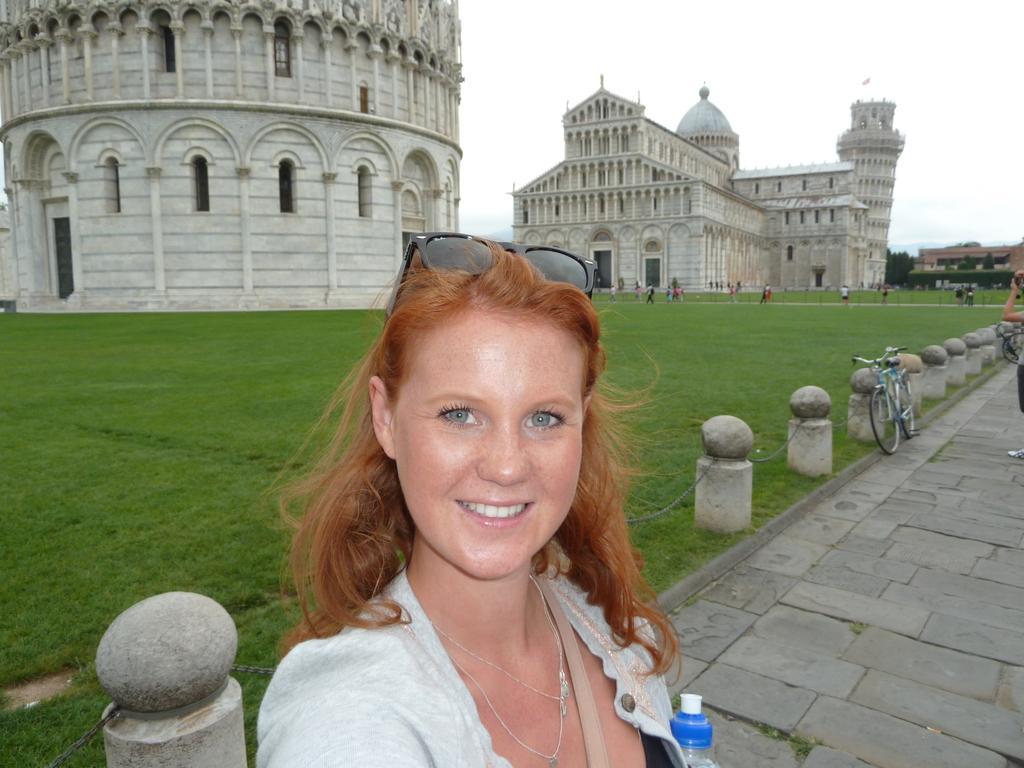Describe this image in one or two sentences. In this image I can see a women in the front and I can also see smile on her face. I can see she is wearing necklace and on her head I can see black colour shades. On the right side of this image I can see two bicycles and one more person. On the bottom side I can see a bottle. In the background I can see number of poles, iron chains, an open grass ground, few buildings and few trees. I can also see number of people are standing in the background. 